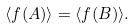<formula> <loc_0><loc_0><loc_500><loc_500>\langle f ( A ) \rangle = \langle f ( B ) \rangle .</formula> 